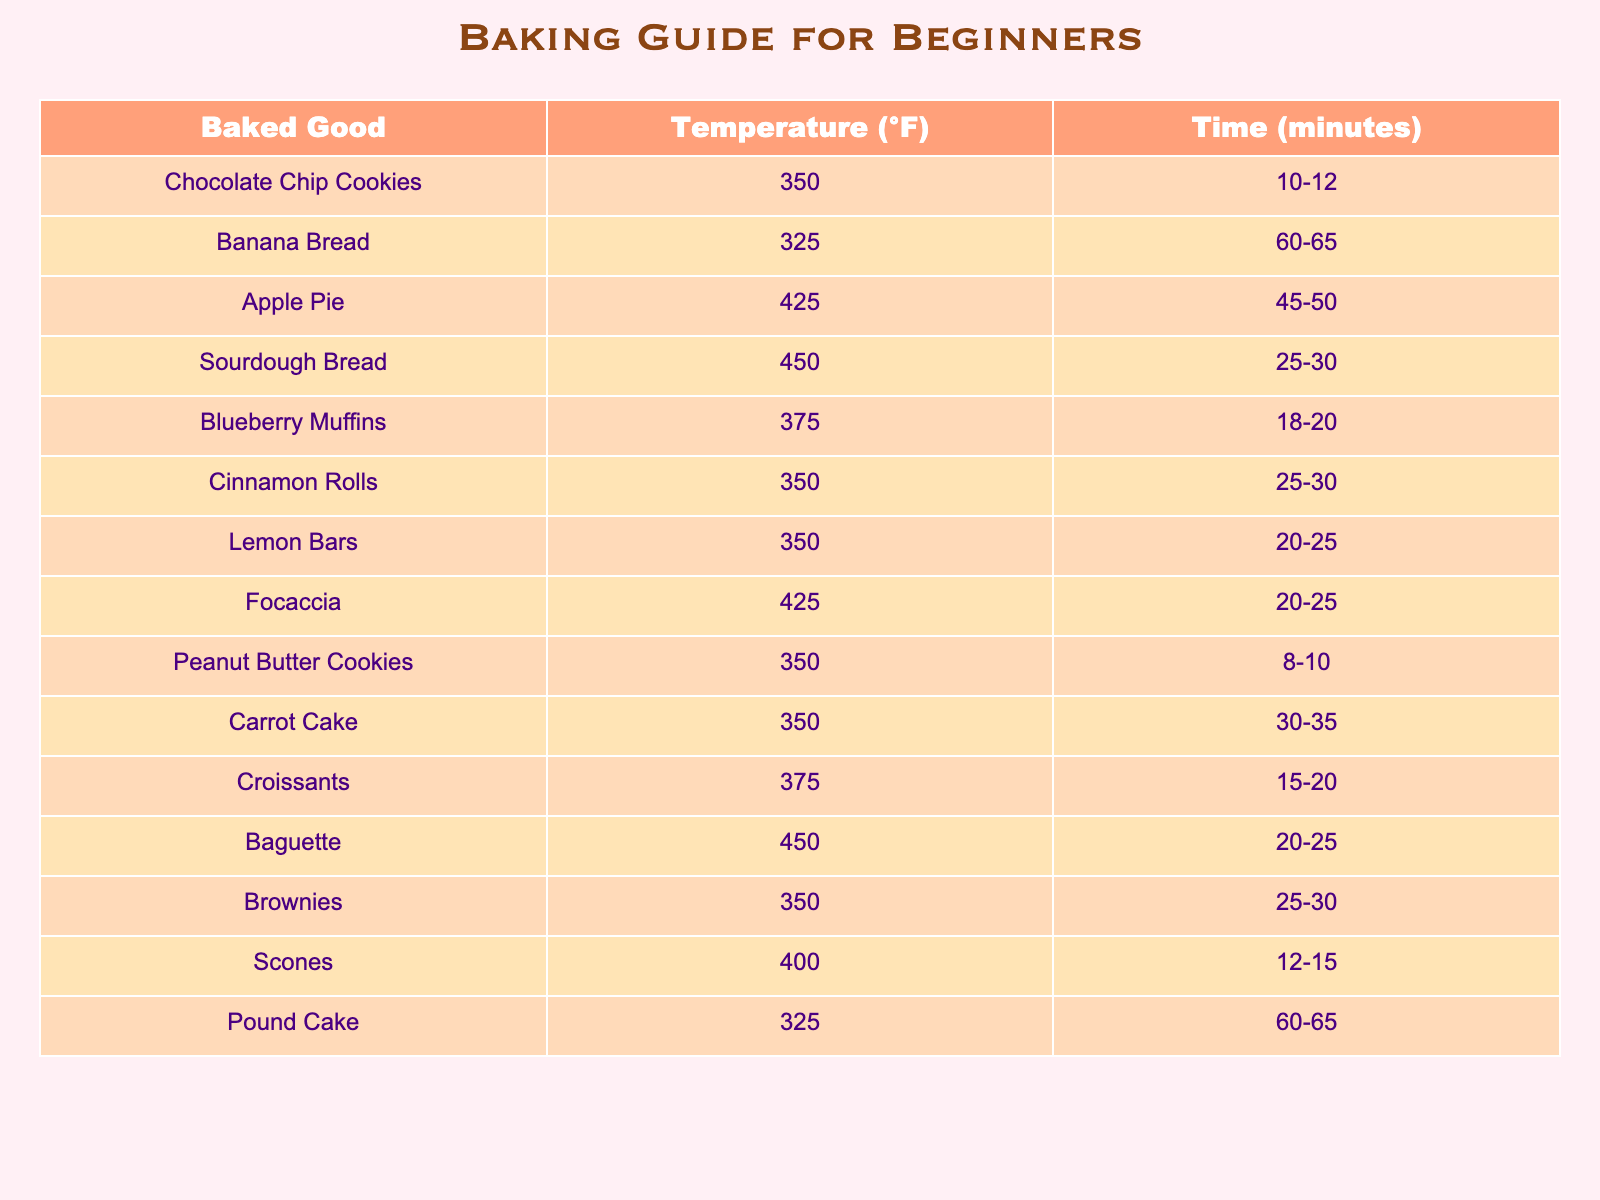What is the baking time for Chocolate Chip Cookies? The table indicates that Chocolate Chip Cookies require a baking time of 10-12 minutes.
Answer: 10-12 minutes What temperature is needed for Banana Bread? According to the table, Banana Bread is baked at a temperature of 325°F.
Answer: 325°F How long do Scones take to bake? The table specifies that Scones take 12-15 minutes to bake.
Answer: 12-15 minutes Is the baking temperature for Apple Pie higher than that for Lemon Bars? Apple Pie is baked at 425°F, while Lemon Bars are baked at 350°F. Since 425 is higher than 350, the statement is true.
Answer: Yes What is the average baking time for Croissants and Focaccia combined? Croissants take 15-20 minutes and Focaccia takes 20-25 minutes. The average of the minimum times is (15 + 20) / 2 = 17.5, and for the maximum times it's (20 + 25) / 2 = 22.5. Therefore, the average time range is 17.5-22.5 minutes.
Answer: 17.5-22.5 minutes Which baked good takes the longest time to bake? Both Banana Bread and Pound Cake require the longest baking time of 60-65 minutes.
Answer: 60-65 minutes Do any cookies bake at 350°F? The table shows that Chocolate Chip Cookies, Cinnamon Rolls, Peanut Butter Cookies, and Brownies all bake at 350°F, so the answer is yes.
Answer: Yes What is the temperature range for baked goods that require 20-25 minutes? In the table, both Focaccia and Baguette are baked at temperatures of 425°F and 450°F, respectively, which shows that the temperature range is 425°F to 450°F.
Answer: 425°F to 450°F How does the baking temperature of Sourdough Bread compare to that of Cinnamon Rolls? Sourdough Bread is baked at 450°F while Cinnamon Rolls are baked at 350°F, making Sourdough Bread's temperature higher.
Answer: Higher If you wanted to bake two types of muffins, what temperatures would you set the oven? The table indicates that Blueberry Muffins are baked at 375°F and that we can only consider one type in this case. Hence, we would set the oven to 375°F for Blueberry Muffins.
Answer: 375°F 